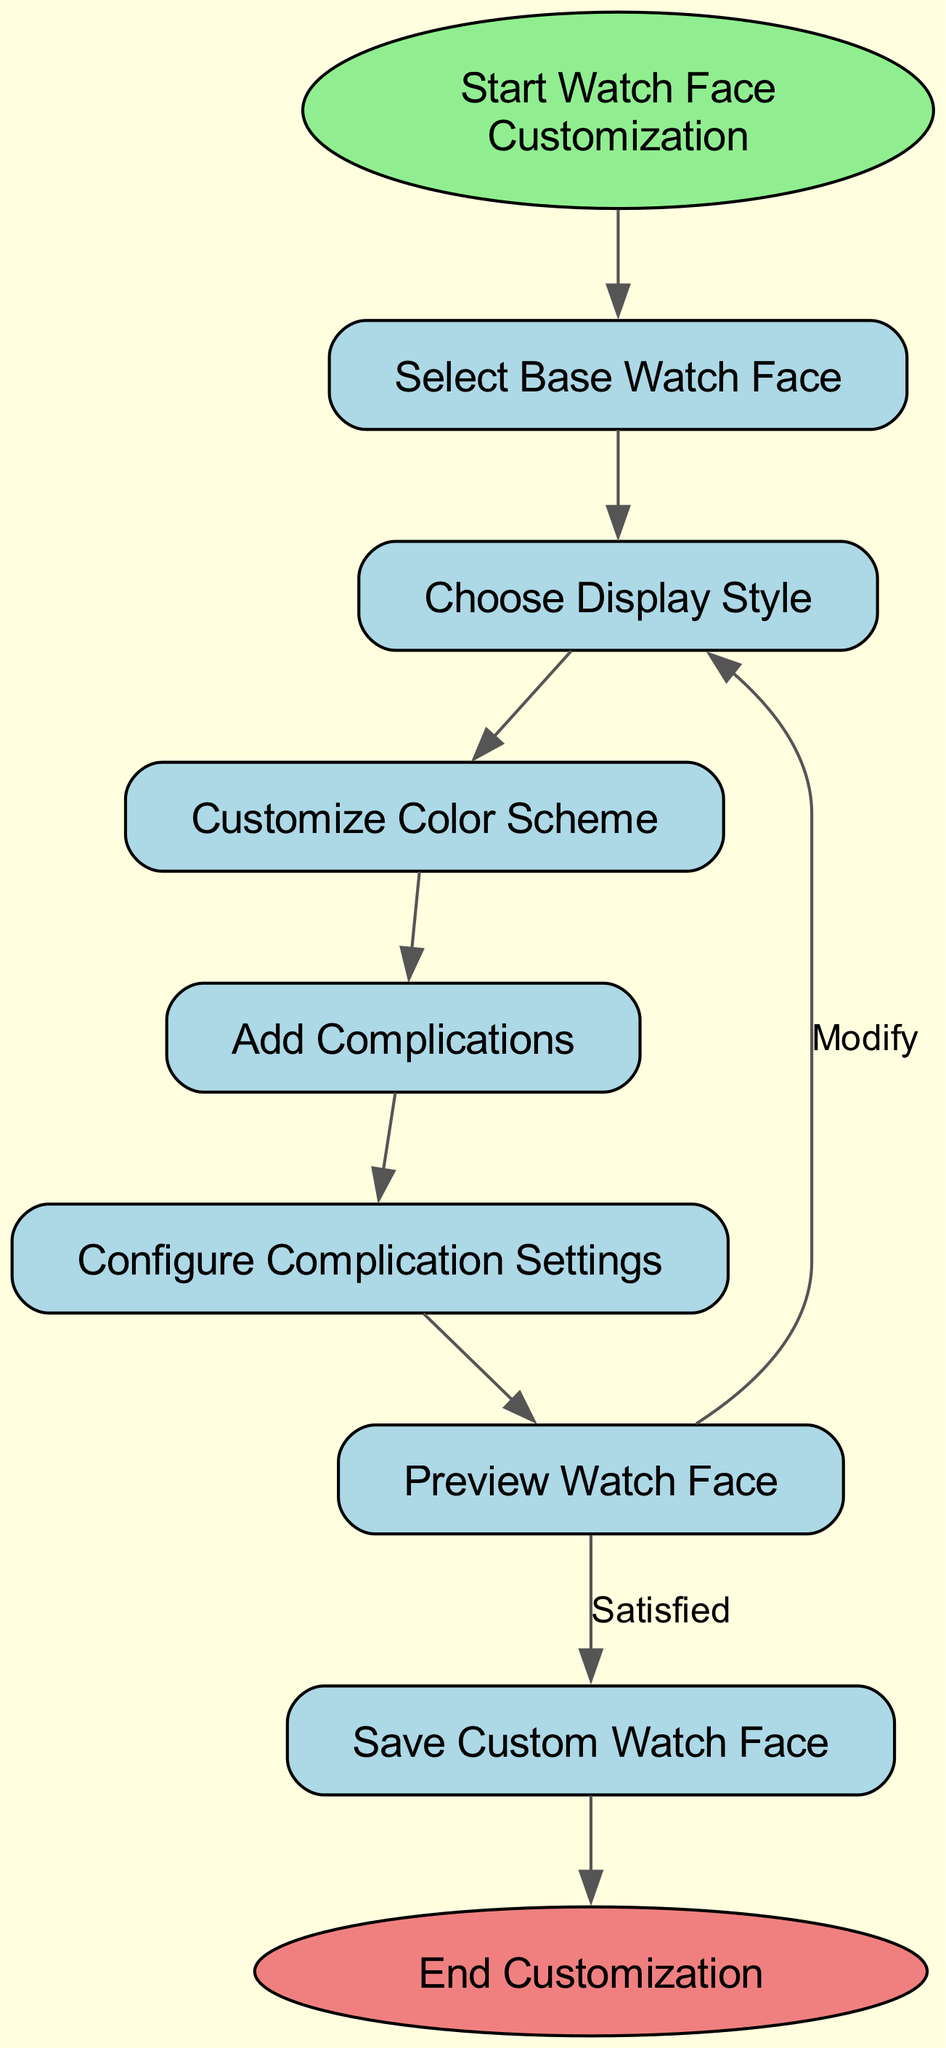What is the first step in the customization process? The diagram starts with the node labeled "Start Watch Face Customization," indicating that this is the first step users encounter in the flow.
Answer: Start Watch Face Customization How many nodes are there in the flowchart? By counting the nodes listed, there are a total of 9 nodes present in the flowchart, including the start and end nodes.
Answer: 9 What occurs immediately after selecting a base watch face? After the "Select Base Watch Face" node, the next step is indicated by an arrow pointing to "Choose Display Style." This shows the sequential flow of the process.
Answer: Choose Display Style What is the final action before ending the customization? The last action that occurs before reaching the "End Customization" node is saving the custom watch face after previewing it. This is indicated by the flow leading to the end node.
Answer: Save Custom Watch Face If the user is dissatisfied with the preview, which step do they return to? If the user is not satisfied with the preview, they will return to the "Choose Display Style" node as indicated by the edge labeled "Modify" leading back to that node.
Answer: Choose Display Style How many edges connect the nodes in the diagram? By counting the edges listed between nodes, there are a total of 8 edges connecting the various steps in the flowchart.
Answer: 8 What type of node signifies the end of the customization process? The end of the customization process is signified by an "End Customization" node, which has an ellipse shape in the diagram.
Answer: End Customization What node follows the customization of the color scheme? After the step of customizing the color scheme, the next node is "Add Complications," as indicated by the directed edge leading from "Customize Color Scheme" to "Add Complications."
Answer: Add Complications Which node allows the user to configure settings for complications? The user can configure settings for complications at the node labeled "Configure Complication Settings," which follows the "Add Complications" node in the flowchart sequence.
Answer: Configure Complication Settings 